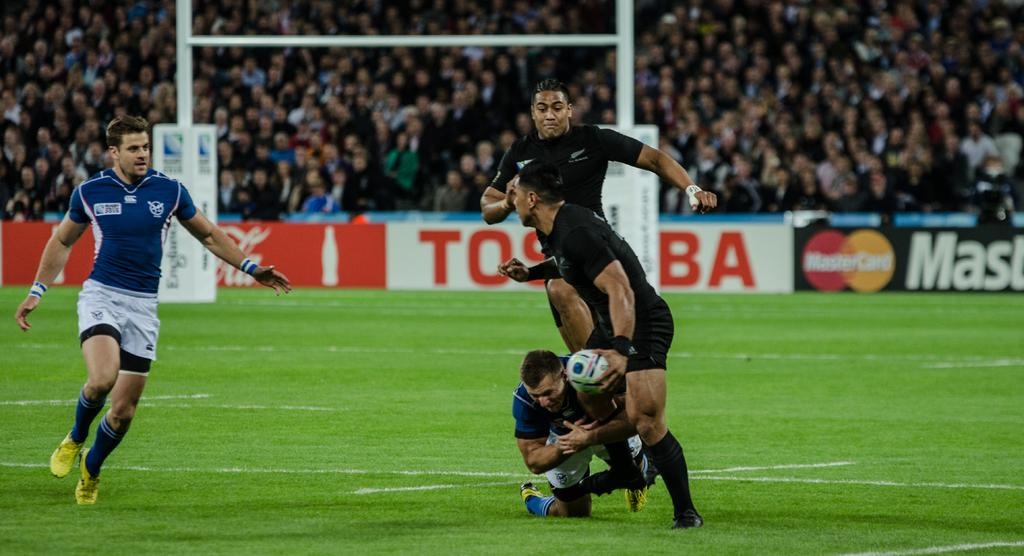What sport are the men playing in the image? The men are playing rugby in the image. Where are the men playing rugby? The men are playing in a playground. What can be seen in the background of the image? There is a hoarding visible in the image, and a crowd is behind the hoarding. How many sheep are present in the image? There are no sheep present in the image. What type of trail can be seen in the image? There is no trail visible in the image. 